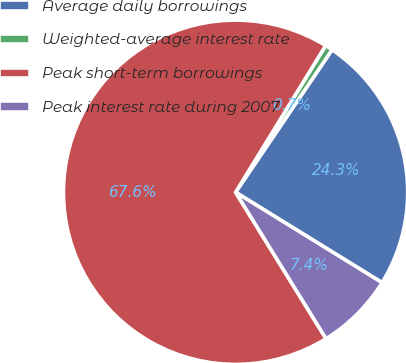<chart> <loc_0><loc_0><loc_500><loc_500><pie_chart><fcel>Average daily borrowings<fcel>Weighted-average interest rate<fcel>Peak short-term borrowings<fcel>Peak interest rate during 2007<nl><fcel>24.33%<fcel>0.71%<fcel>67.57%<fcel>7.39%<nl></chart> 